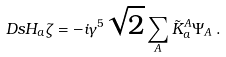<formula> <loc_0><loc_0><loc_500><loc_500>\ D s H _ { a } \zeta = - i \gamma ^ { 5 } \sqrt { 2 } \sum _ { A } \tilde { K } _ { a } ^ { A } \Psi _ { A } \, .</formula> 